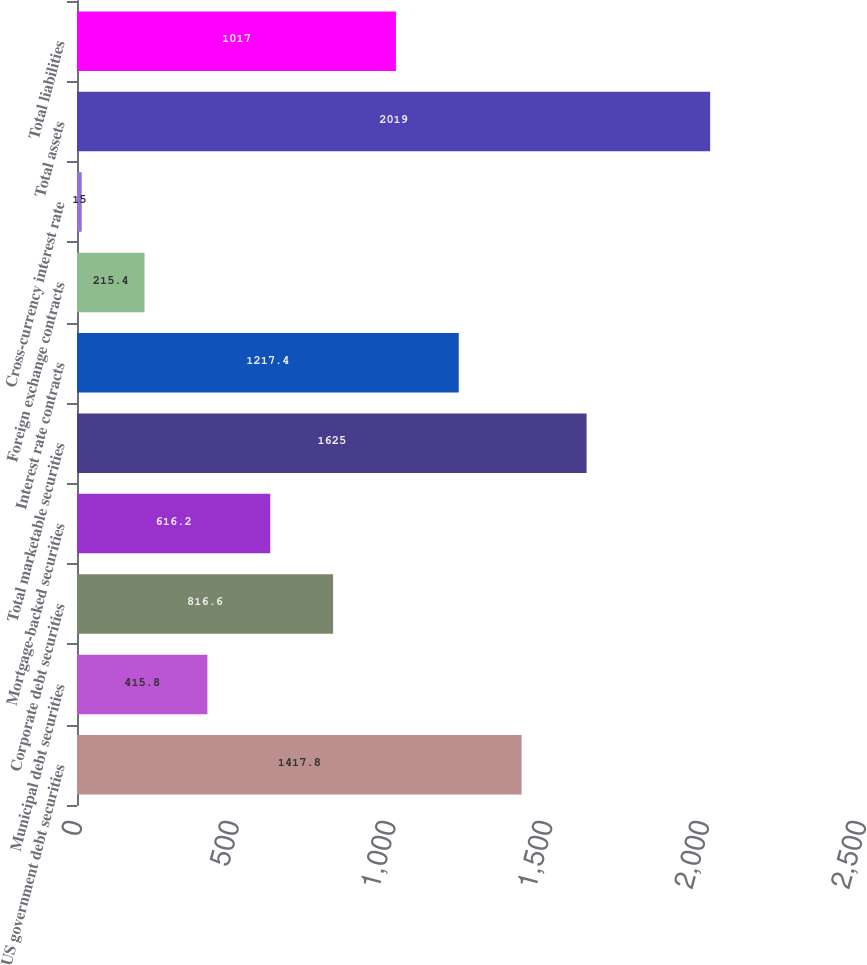<chart> <loc_0><loc_0><loc_500><loc_500><bar_chart><fcel>US government debt securities<fcel>Municipal debt securities<fcel>Corporate debt securities<fcel>Mortgage-backed securities<fcel>Total marketable securities<fcel>Interest rate contracts<fcel>Foreign exchange contracts<fcel>Cross-currency interest rate<fcel>Total assets<fcel>Total liabilities<nl><fcel>1417.8<fcel>415.8<fcel>816.6<fcel>616.2<fcel>1625<fcel>1217.4<fcel>215.4<fcel>15<fcel>2019<fcel>1017<nl></chart> 